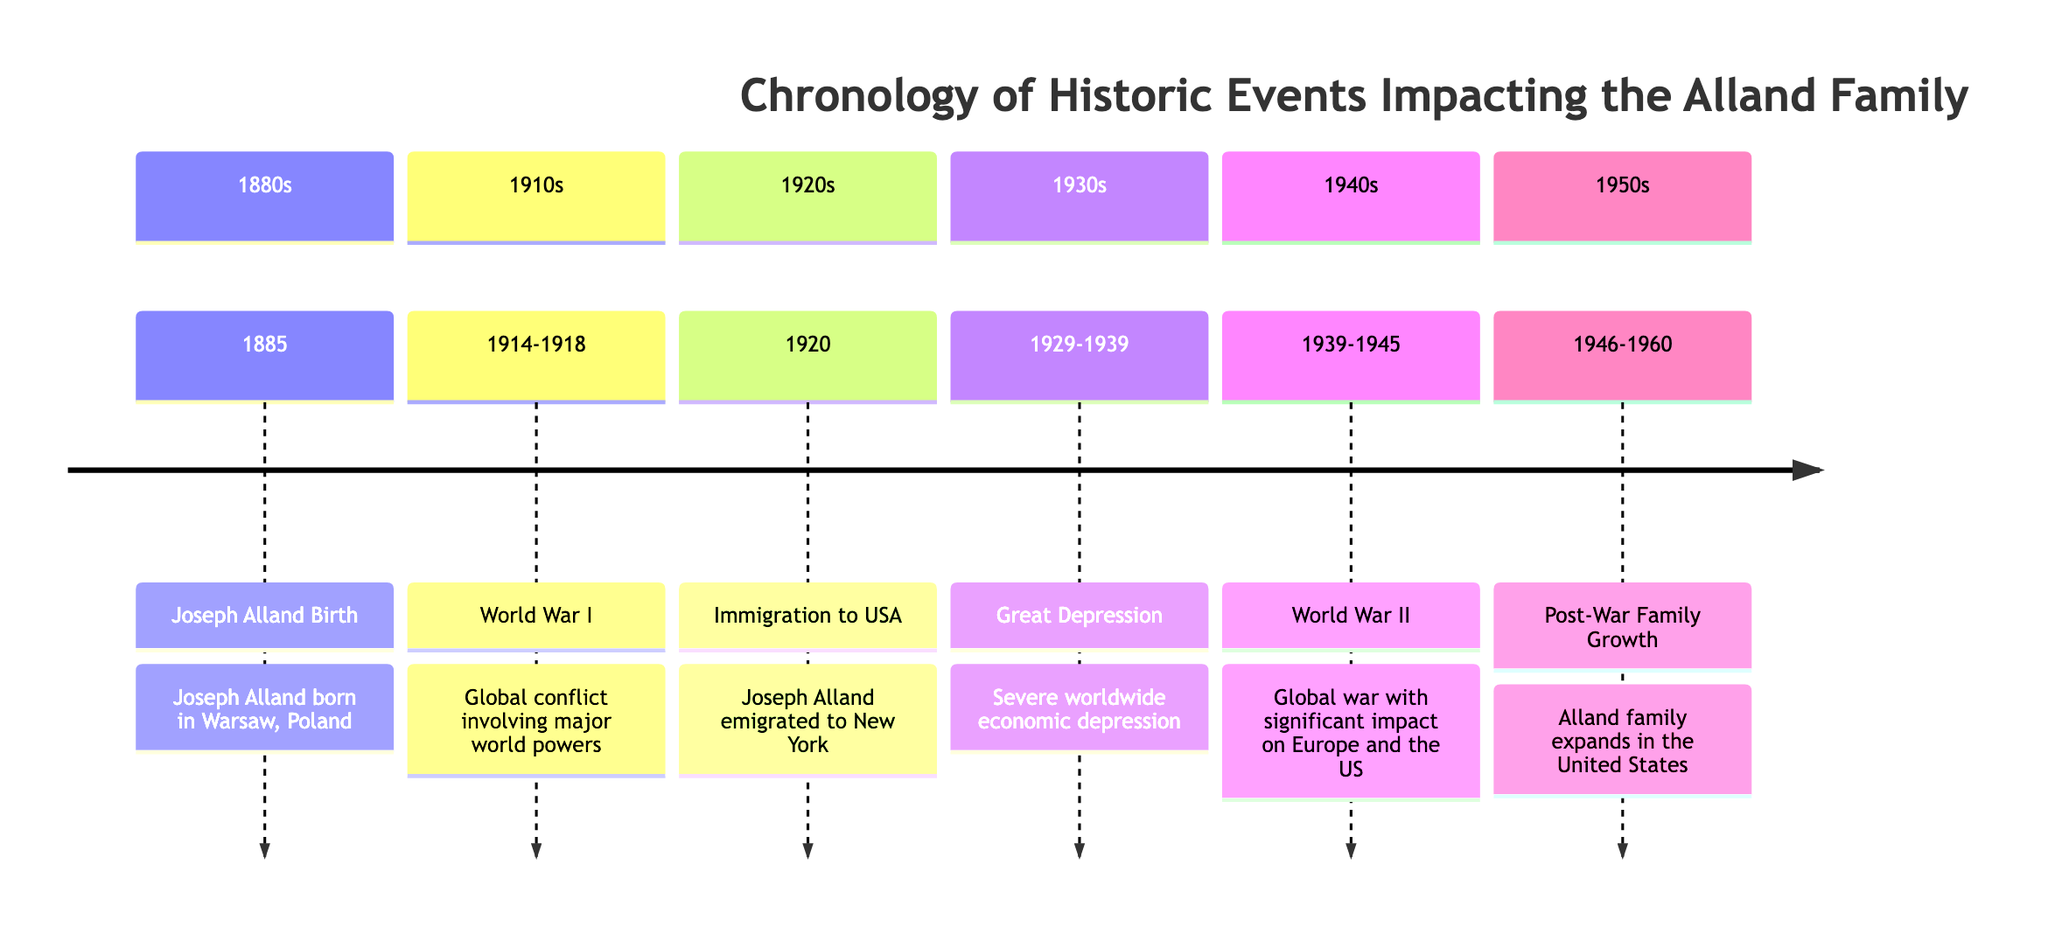What year did Joseph Alland emigrate to the USA? The diagram indicates the event "Immigration to USA" associated with Joseph Alland, which is specifically dated as 1920.
Answer: 1920 What major global conflict occurred between 1914 and 1918? Referring to the section labeled "1910s," the diagram identifies "World War I" as the significant global conflict during these years.
Answer: World War I How many distinct sections are there in the diagram? By counting the sections from the diagram, there are six distinct sections: 1880s, 1910s, 1920s, 1930s, 1940s, and 1950s.
Answer: 6 What event marked the death of Joseph Alland in the diagram? The diagram does not list an event related to the death of Joseph Alland, indicating that such an event is either unspecified or not included in the presented timeline.
Answer: Not specified During which decade did the Great Depression occur? According to the diagram, the "Great Depression" is marked to have occurred from 1929 to 1939, which falls during the 1930s decade.
Answer: 1930s What significant change in the Alland family is noted for the 1950s? The section labeled "Post-War Family Growth" describes the expansion of the Alland family in the United States during the 1946-1960 time frame, marking a significant change for that decade.
Answer: Family Expansion Which event directly follows Joseph Alland's birth in the timeline? After "Joseph Alland Birth" in the 1880s, World War I occurs in the 1910s, indicating that this global conflict directly follows his birth.
Answer: World War I What significant worldwide event happened during the 1940s? The timeline features "World War II" as a major global event that occurred in the 1940s, specifically from 1939 to 1945.
Answer: World War II What are the years during which the Alland family grew post-war? The diagram cites the years 1946 to 1960 in the context of "Post-War Family Growth," indicating a span of years for this event.
Answer: 1946-1960 